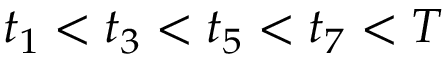<formula> <loc_0><loc_0><loc_500><loc_500>t _ { 1 } < t _ { 3 } < t _ { 5 } < t _ { 7 } < T</formula> 